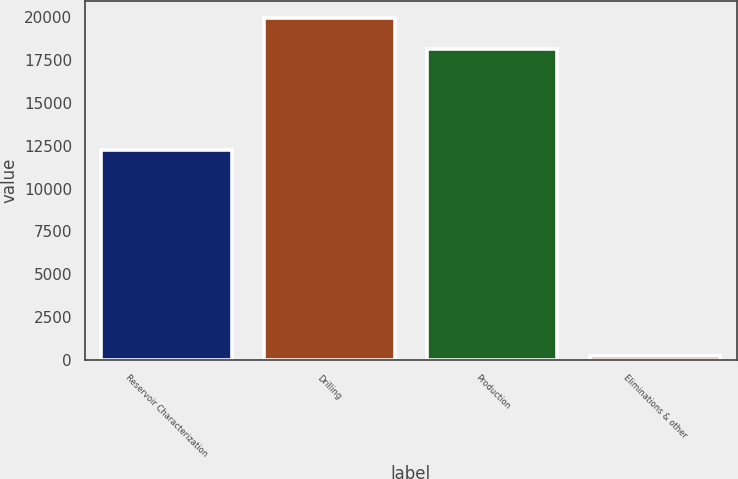Convert chart to OTSL. <chart><loc_0><loc_0><loc_500><loc_500><bar_chart><fcel>Reservoir Characterization<fcel>Drilling<fcel>Production<fcel>Eliminations & other<nl><fcel>12224<fcel>19935.5<fcel>18111<fcel>217<nl></chart> 